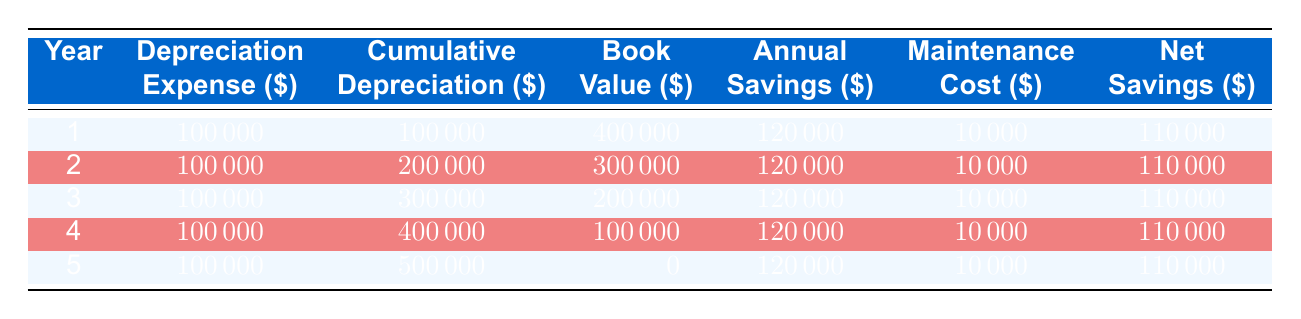What is the annual depreciation expense for each year? From the table, the annual depreciation expense for each year is consistently shown as 100000 for all years from 1 to 5.
Answer: 100000 What is the cumulative depreciation at the end of year 3? According to the table, the cumulative depreciation at the end of year 3 is shown as 300000.
Answer: 300000 What is the net savings for the first year? The net savings for the first year is provided in the table as 110000.
Answer: 110000 Is the book value in year 5 zero? The table states that the book value at the end of year 5 is indeed 0.
Answer: Yes What is the total depreciation expense over the 5-year period? To find the total depreciation expense, we add the depreciation expense for each year: 100000 + 100000 + 100000 + 100000 + 100000 = 500000.
Answer: 500000 What are the annual savings in the 4th year? The table shows that the annual savings in year 4 is listed as 120000.
Answer: 120000 What is the average annual maintenance cost over the 5 years? The annual maintenance cost for each year is consistently 10000. The total for 5 years is 10000 * 5 = 50000, and the average is 50000 / 5 = 10000.
Answer: 10000 What is the difference in book value between year 2 and year 4? The book value in year 2 is 300000 and in year 4 is 100000. The difference is 300000 - 100000 = 200000.
Answer: 200000 Is the net savings the same for all years? The table indicates that the net savings is consistently 110000 for each year.
Answer: Yes 